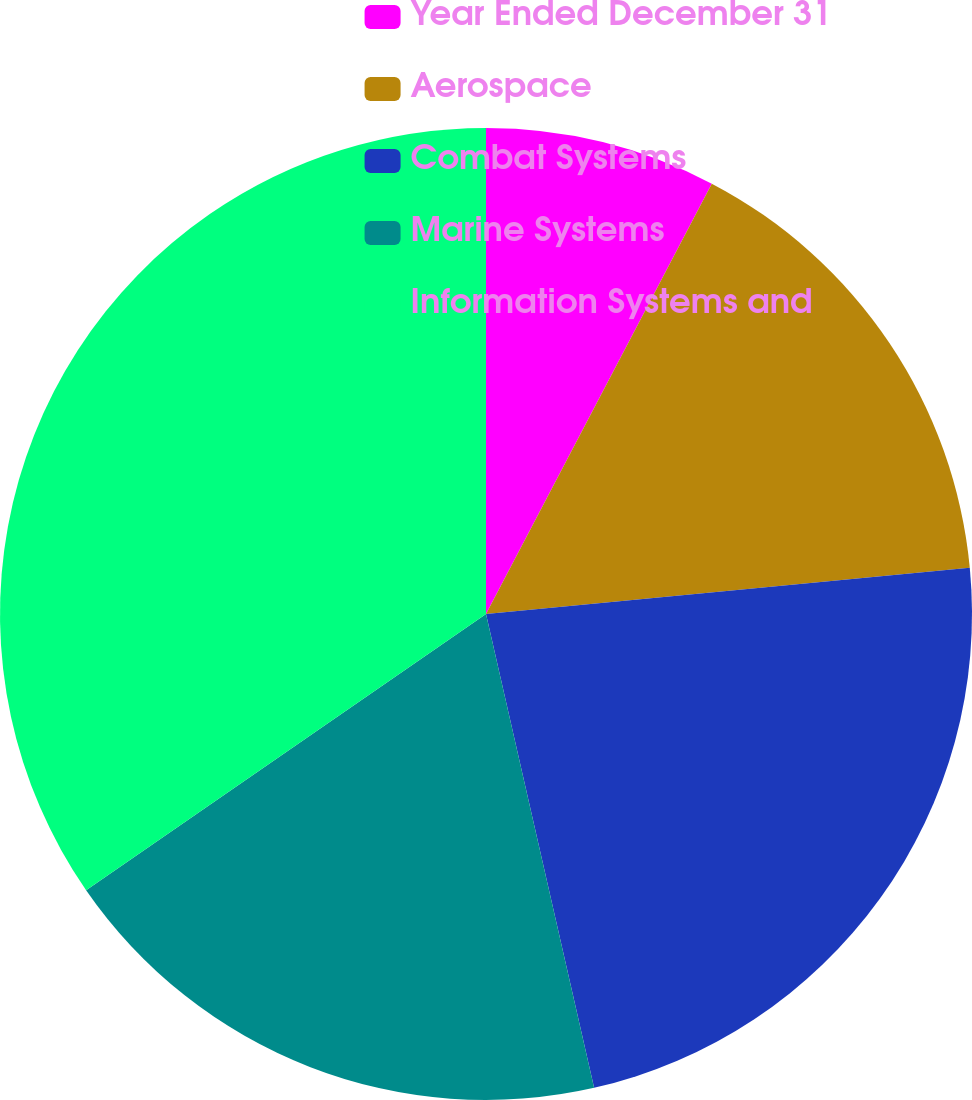<chart> <loc_0><loc_0><loc_500><loc_500><pie_chart><fcel>Year Ended December 31<fcel>Aerospace<fcel>Combat Systems<fcel>Marine Systems<fcel>Information Systems and<nl><fcel>7.69%<fcel>15.79%<fcel>22.95%<fcel>18.95%<fcel>34.62%<nl></chart> 